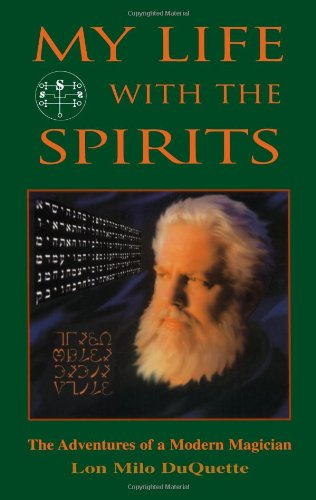Who is the author of this book? The author of the book shown in the image is Lon Milo DuQuette, an American writer, and musician known for his works on occult and esoteric subjects. 